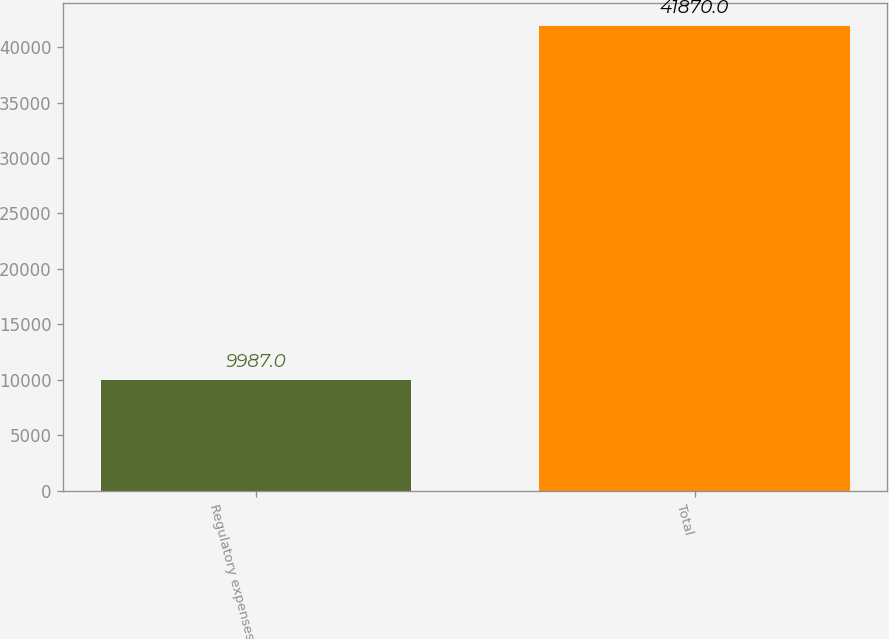Convert chart. <chart><loc_0><loc_0><loc_500><loc_500><bar_chart><fcel>Regulatory expenses<fcel>Total<nl><fcel>9987<fcel>41870<nl></chart> 